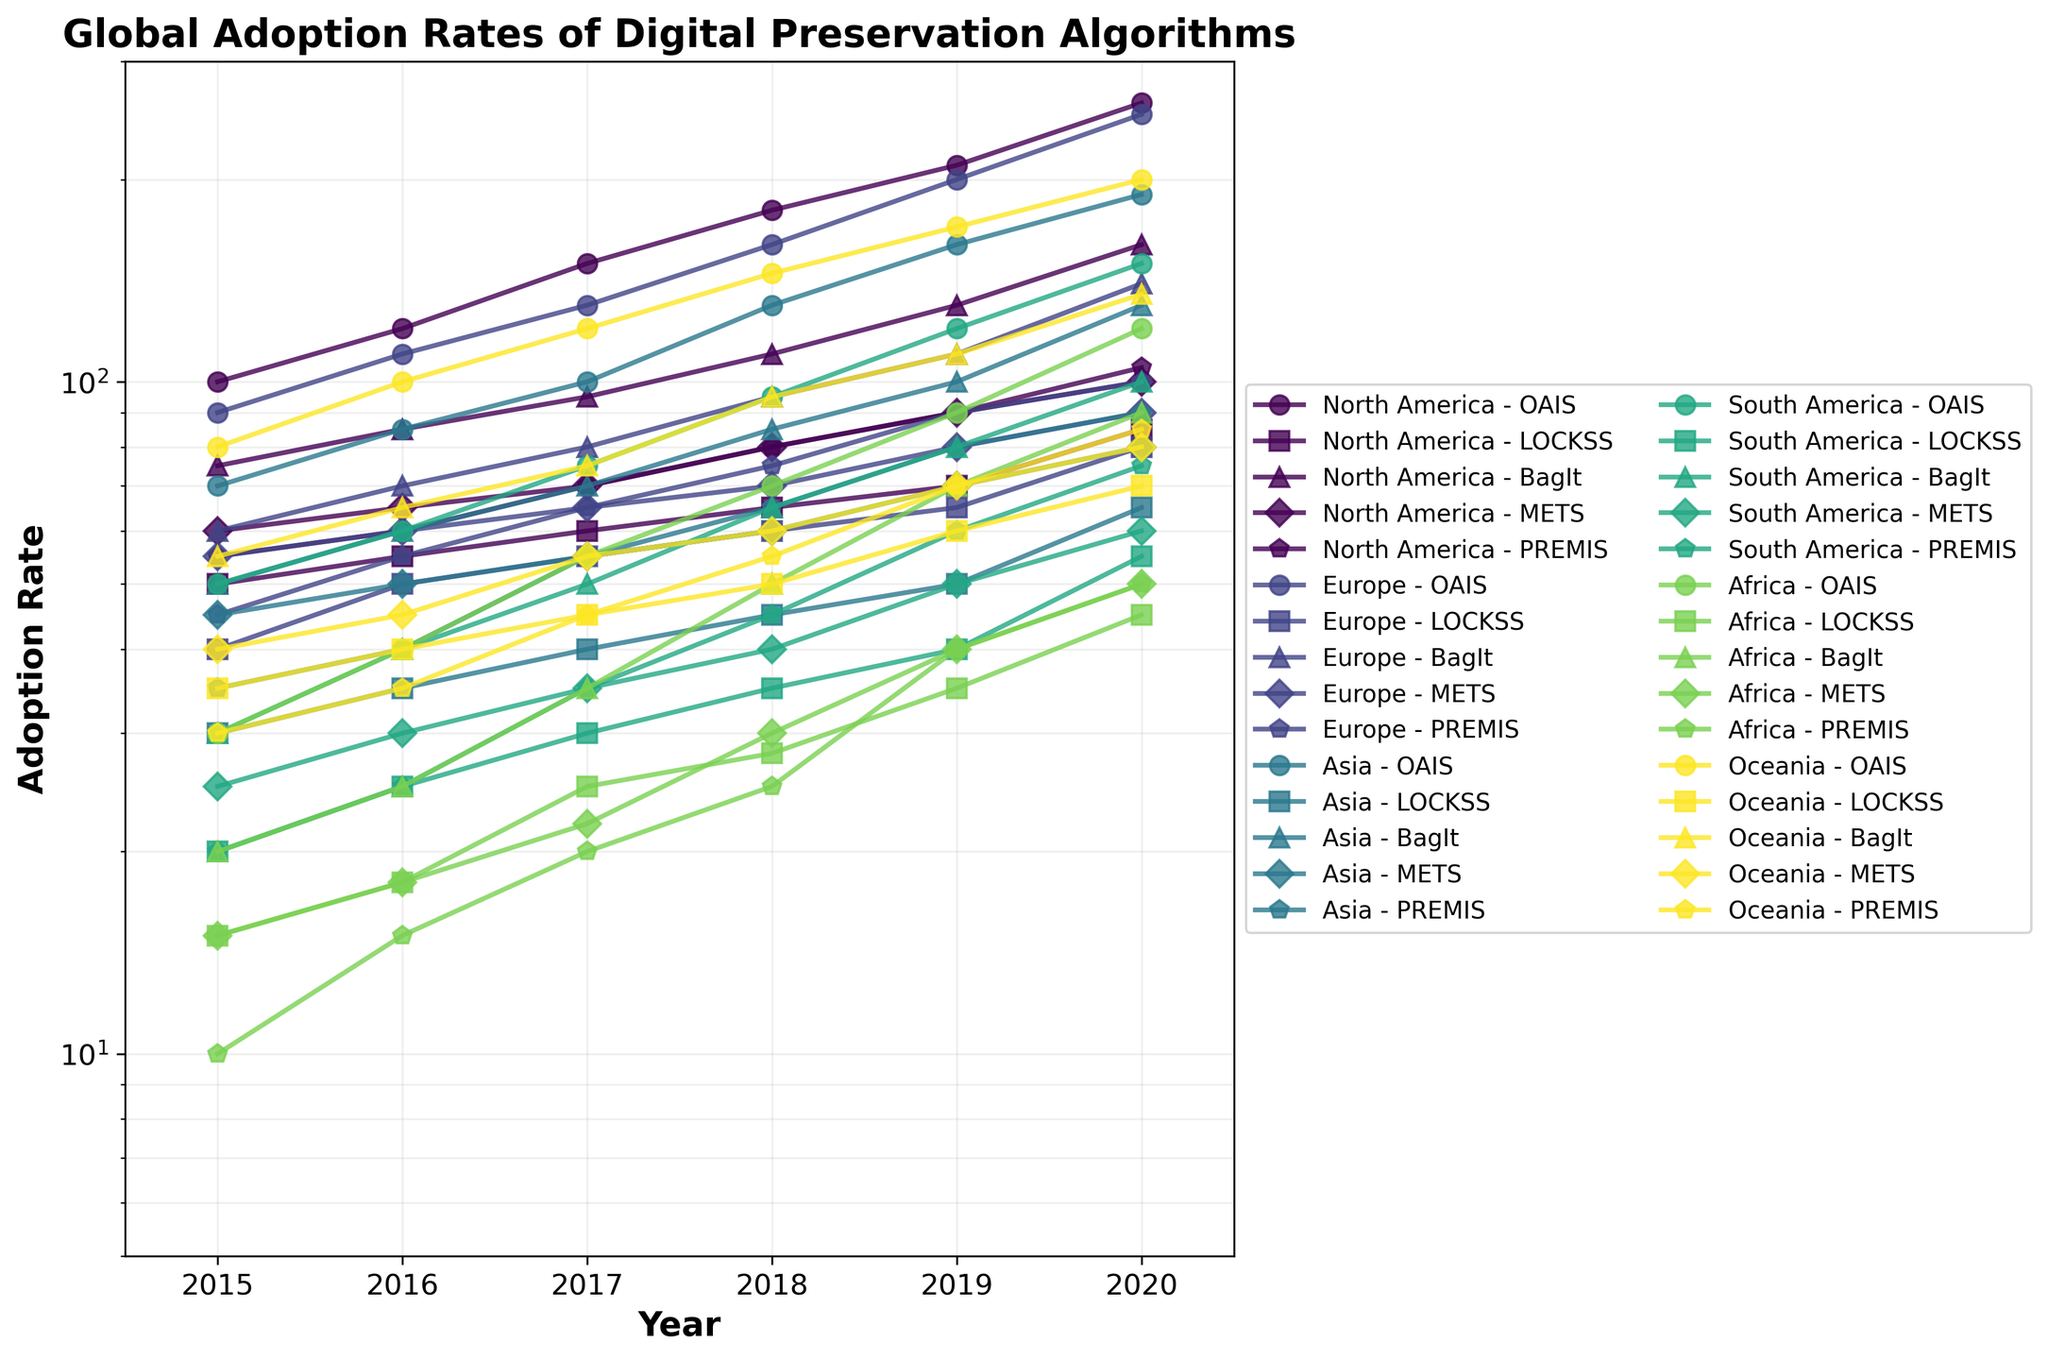What is the title of the figure? The title of the figure is displayed at the top, summarizing the main subject of the plot.
Answer: Global Adoption Rates of Digital Preservation Algorithms Which regions have data points from 2015 to 2020? The regions with data points spanning from 2015 to 2020 can be determined by checking the series in the plot.
Answer: North America, Europe, Asia, South America, Africa, Oceania How does the adoption rate of the OAIS algorithm in North America change from 2015 to 2020? To see how the OAIS adoption rate changes, follow the line for North America - OAIS from 2015 to 2020. The rate increases each year.
Answer: It increases Which algorithm in Oceania shows the highest adoption rate in 2020? To identify this, locate 2020 on the x-axis and check the algorithms plotted for Oceania. The OAIS algorithm has the highest value.
Answer: OAIS Compare the adoption rates of METS in 2019 between Europe and South America. Which one is higher and by how much? Compare the METS values for Europe and South America at 2019. METS in Europe is 80, and in South America, it is 50. The difference is 30.
Answer: Europe, by 30 What is the range of adoption rates for the BagIt algorithm in Asia from 2015 to 2020? To find this range, note the minimum and maximum values for BagIt in Asia from 2015 to 2020. The values range from 50 to 130.
Answer: 50 to 130 Which region experienced the most significant increase in the adoption rate of the PREMIS algorithm from 2019 to 2020? To determine this, look at the PREMIS adoption rate for each region in 2019 and 2020 and calculate the differences. The North America region shows the largest increase from 90 to 105, which is 15.
Answer: North America Is the trend of the LOCKSS adoption rate in Africa generally increasing, decreasing, or stable from 2015 to 2020? Trace the line corresponding to the LOCKSS adoption rate in Africa from 2015 to 2020. The trend generally shows an increase.
Answer: Increasing How many unique markers are used in the figure, and what do they represent? Count the number of different marker styles seen in the plot. Each unique marker represents a different algorithm. There are five unique markers.
Answer: 5 markers representing 5 algorithms What is the log scale y-axis useful for in this plot? A log scale y-axis helps in better visual representation of data that spans a large range of values, allowing smaller values and larger values to be viewed together effectively. This makes it easier to compare growth rates and trends.
Answer: Representing large data variations 